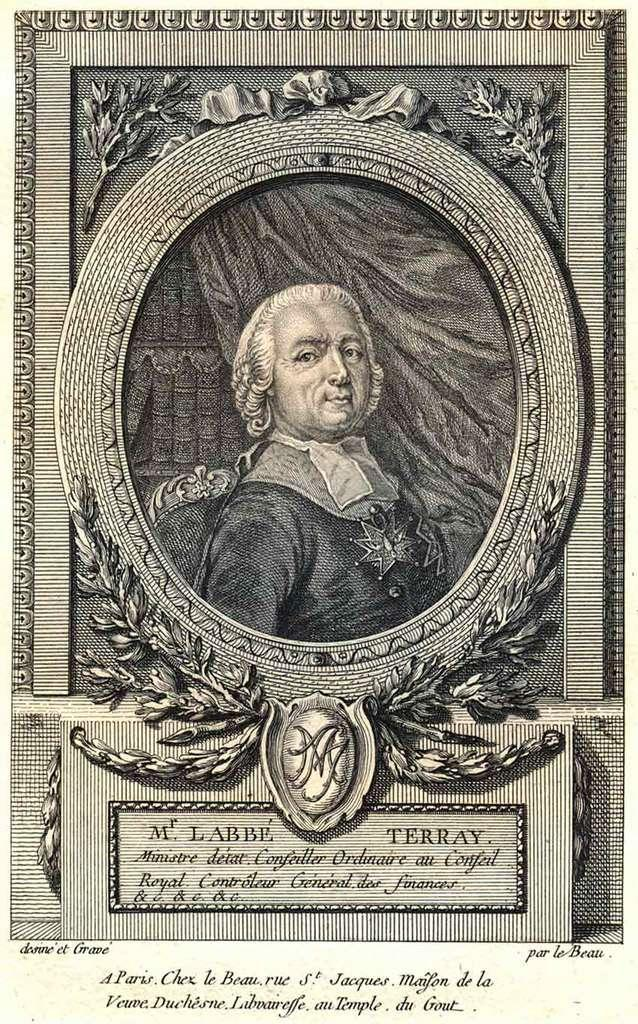<image>
Present a compact description of the photo's key features. A historical lithograph of a man features M. Labbe Terra'y. 